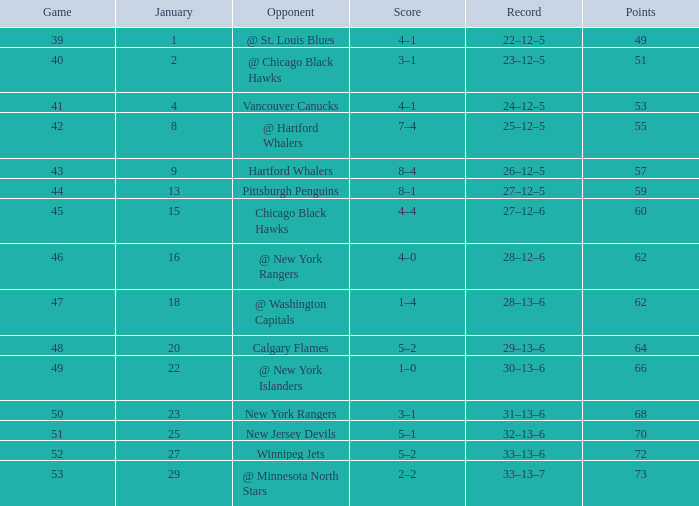How many games have a Score of 1–0, and Points smaller than 66? 0.0. 